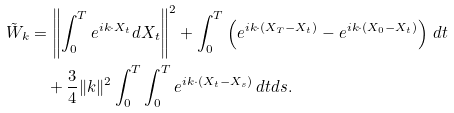<formula> <loc_0><loc_0><loc_500><loc_500>\tilde { W } _ { k } & = \left \| \int _ { 0 } ^ { T } e ^ { i k \cdot X _ { t } } d X _ { t } \right \| ^ { 2 } + \real \int _ { 0 } ^ { T } \left ( e ^ { i k \cdot ( X _ { T } - X _ { t } ) } - e ^ { i k \cdot ( X _ { 0 } - X _ { t } ) } \right ) \, d t \\ & \quad + \frac { 3 } { 4 } \| k \| ^ { 2 } \real \int _ { 0 } ^ { T } \int _ { 0 } ^ { T } e ^ { i k \cdot ( X _ { t } - X _ { s } ) } \, d t d s .</formula> 